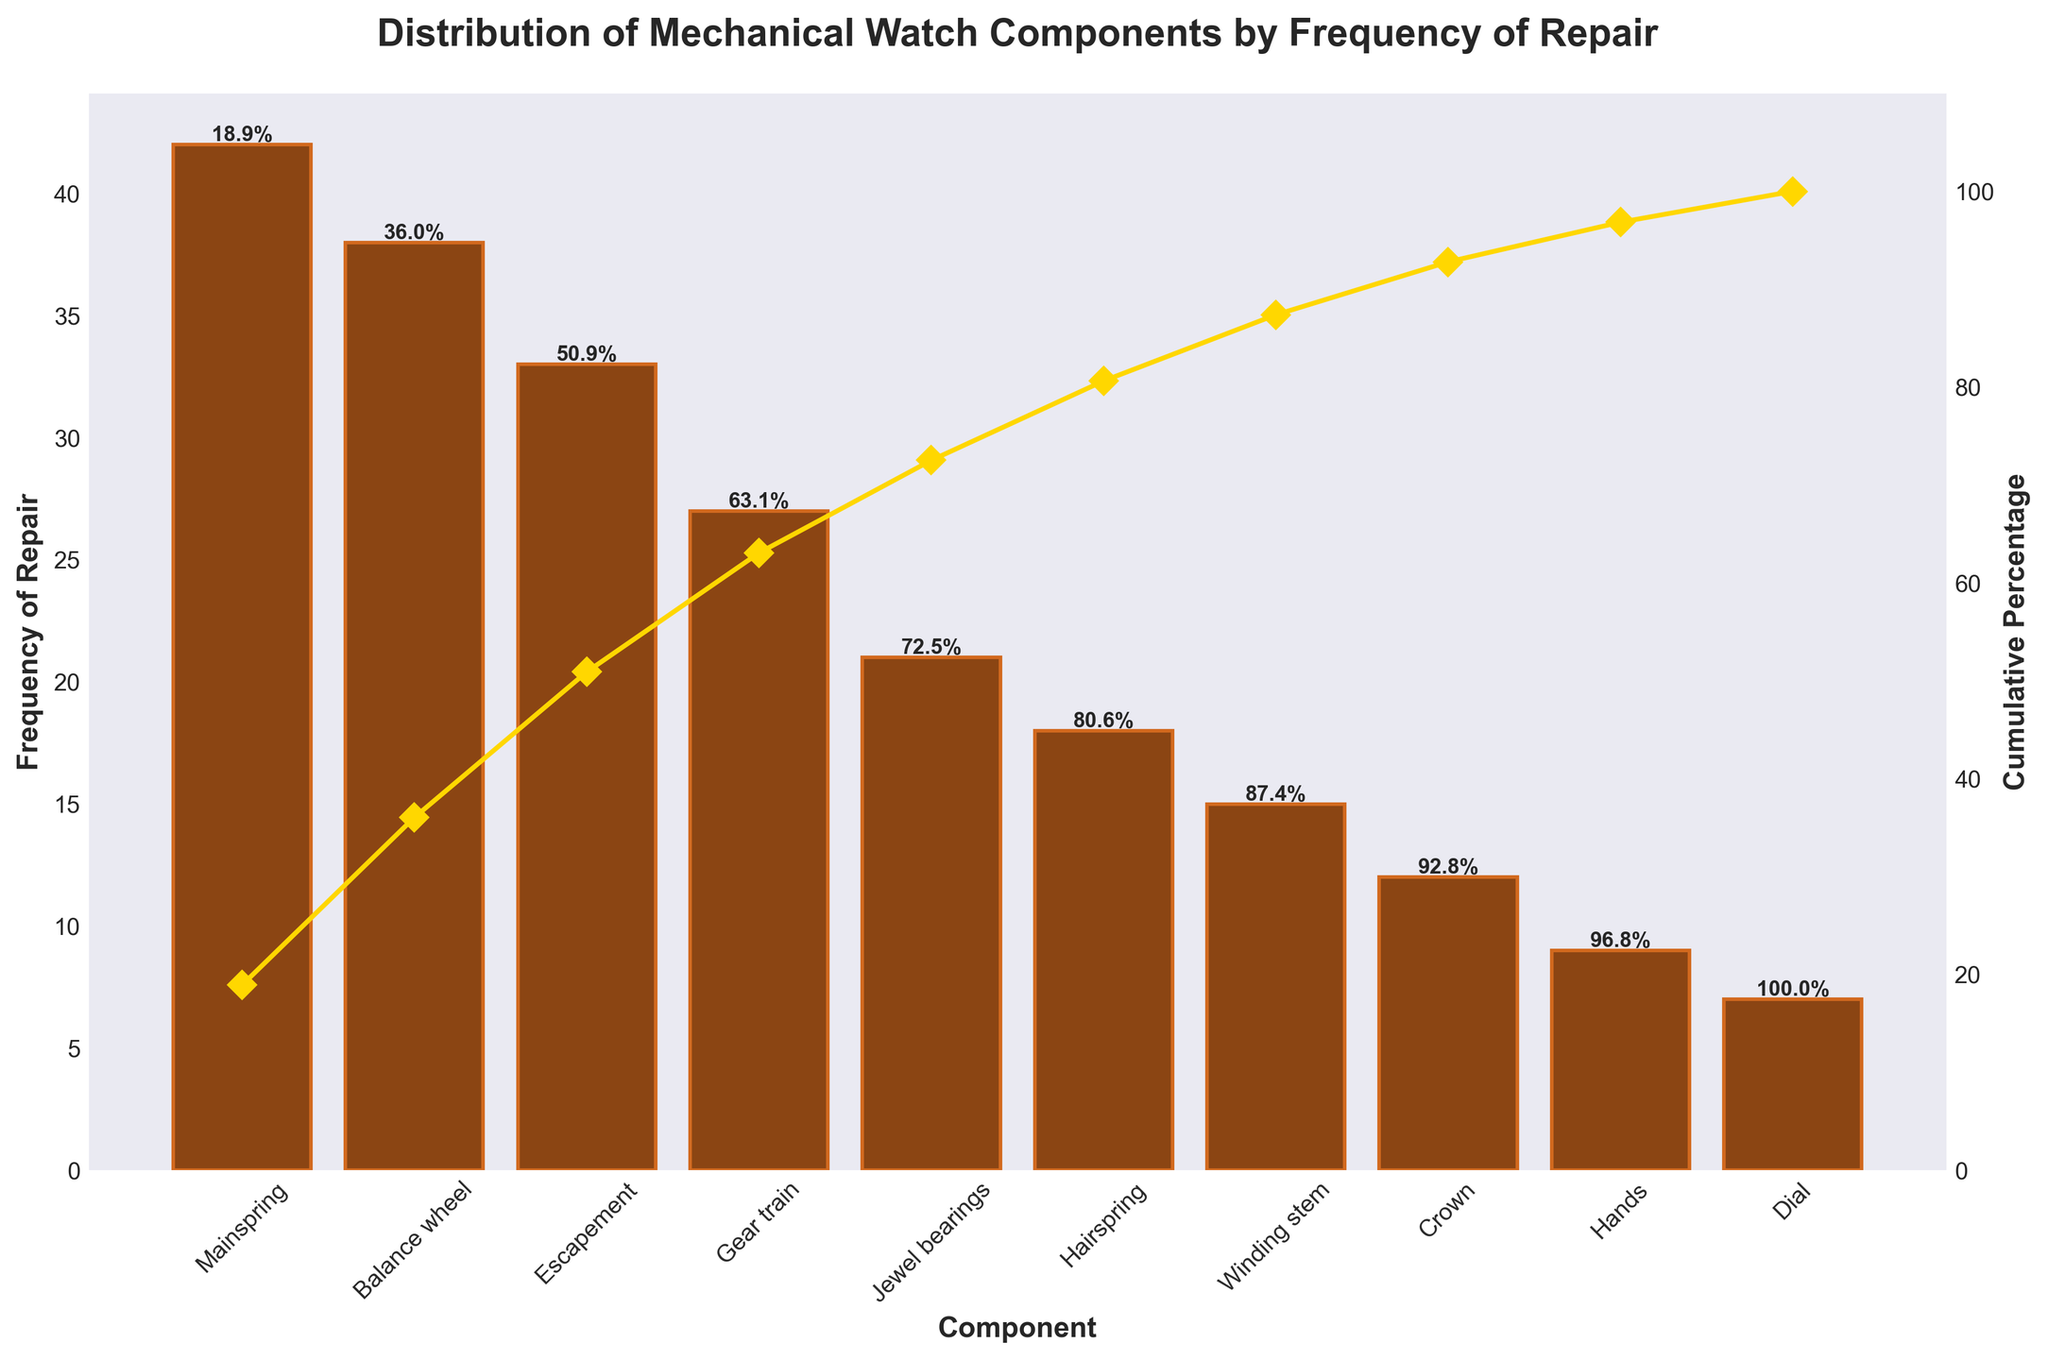What's the title of the chart? The title of the chart is located at the top and is clearly written in bold text.
Answer: Distribution of Mechanical Watch Components by Frequency of Repair How many components have a frequency of repair over 30? By examining the bar heights and the labels, we can see which bars have a frequency above 30. There are three components: Mainspring (42), Balance wheel (38), and Escapement (33).
Answer: 3 What is the cumulative percentage of repair for the top three components? To find this, you look at the cumulative percentage value next to the top three bars. For the Mainspring, Balance wheel, and Escapement, the cumulative percentages are shown as 22.3%, 42.5%, and 60.1%, respectively.
Answer: 60.1% What is the color of the bars representing the frequency of repair? The bars' color can be identified by looking at the chart. The bars are colored in a shade of brown.
Answer: Brown Which component has the lowest frequency of repair, and what is its value? The lowest bar on the chart, located for the 'Dial', indicates the lowest frequency of repair. The exact number can be read from the label on that bar.
Answer: Dial, 7 Which component is repaired more frequently: the Crown or the Dial? By comparing the heights of the bars representing Crown and Dial, it is clear that the Crown's bar is taller than the Dial's bar. The Crown has a frequency of 12 while the Dial has 7.
Answer: Crown What percentage of repairs is made up by the top five components? We need to look at the cumulative percentage next to the fifth bar (Jewel bearings). The cumulative percentage for the top five components is given as 83.5%.
Answer: 83.5% How much higher is the frequency of repair for the Mainspring compared to the Hairspring? Subtract the Hairspring's frequency (18) from the Mainspring's frequency (42). The difference is 42 - 18 = 24.
Answer: 24 Which component shows the steepest jump in cumulative percentage when added? By analyzing the line plot of cumulative percentage, the steepest jump can be observed between the Mainspring and the Balance wheel. The jump from 22.3% to 42.5% is the steepest.
Answer: Balance wheel What is the cumulative percentage when we include the Winding stem? The cumulative percentage when the Winding Stem is included can be observed on the curve at its corresponding point. The value next to the Winding Stem is 83.5% (including Winding stem, the sixth component).
Answer: 83.5% 